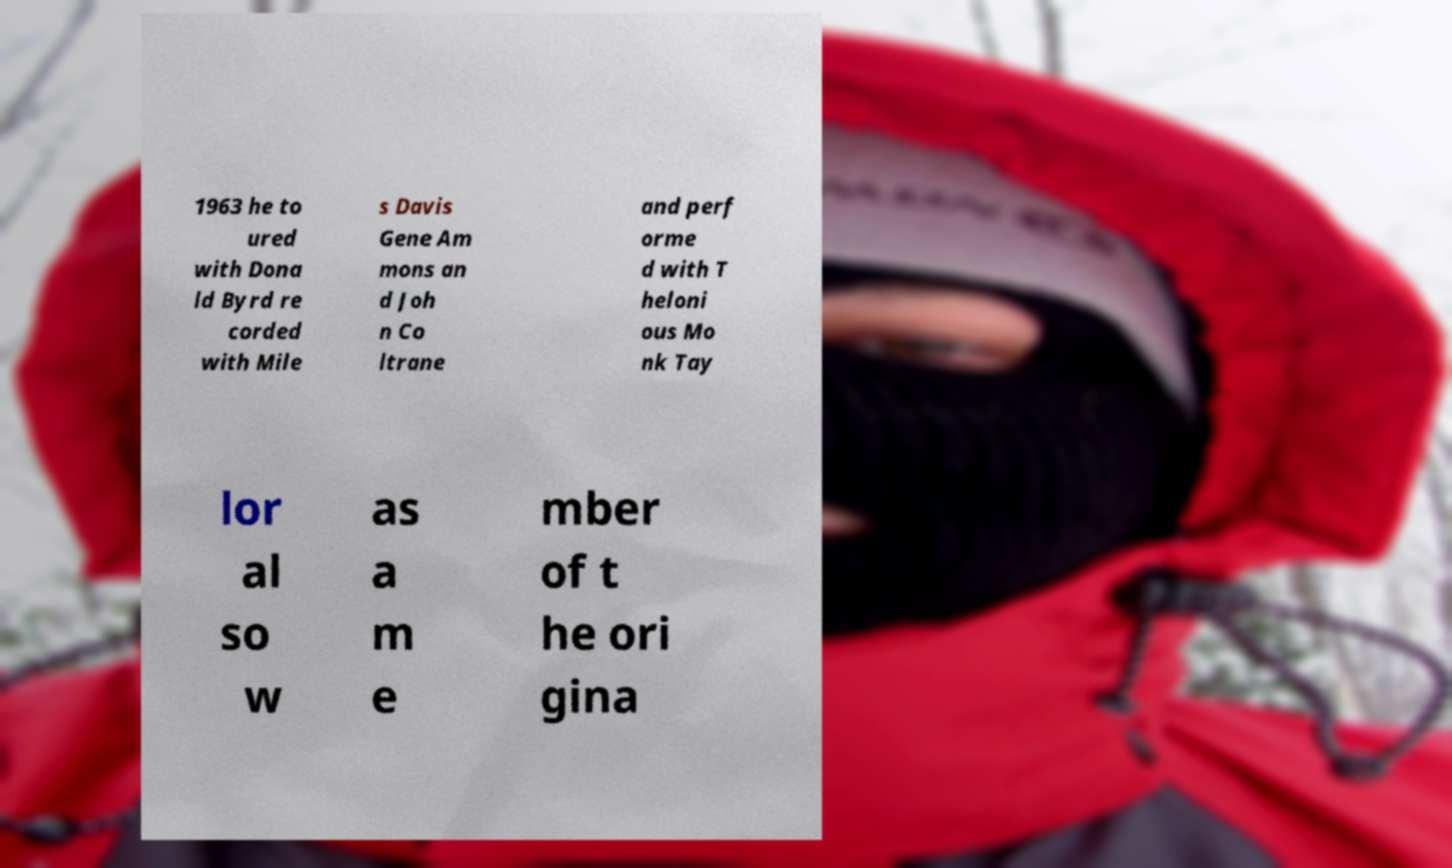Please identify and transcribe the text found in this image. 1963 he to ured with Dona ld Byrd re corded with Mile s Davis Gene Am mons an d Joh n Co ltrane and perf orme d with T heloni ous Mo nk Tay lor al so w as a m e mber of t he ori gina 